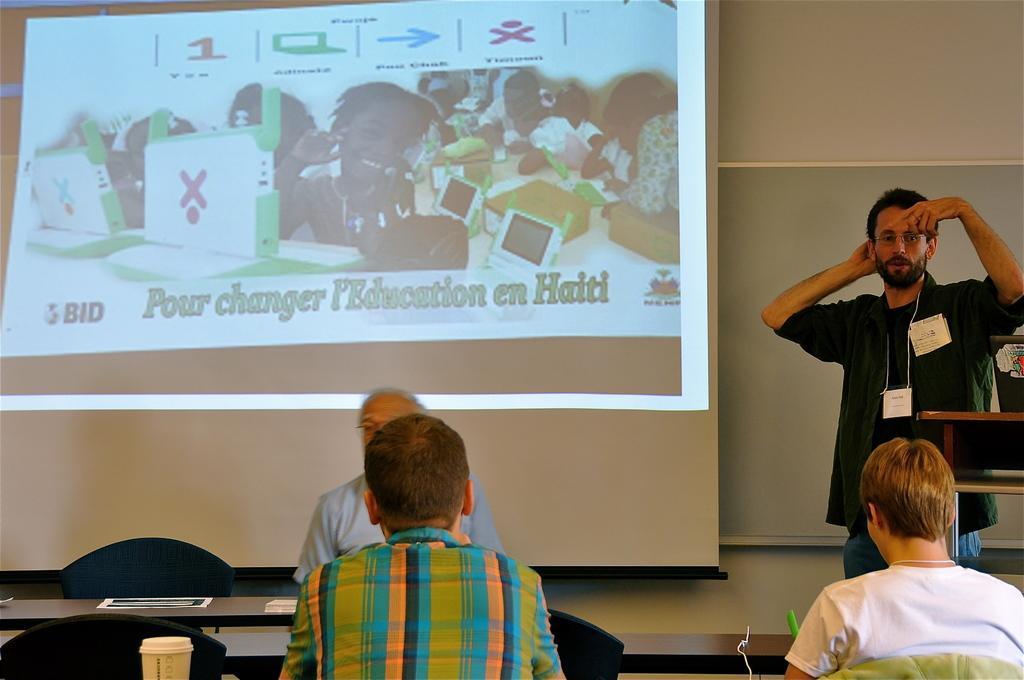In one or two sentences, can you explain what this image depicts? In this image, we can see four persons. Here three persons are sitting. At the bottom of the image, we can see chairs, tables and few things. On the rights die of the image, we can see a person is standing and talking. Here there is a laptop on the object. Background we can see screen and wall. 